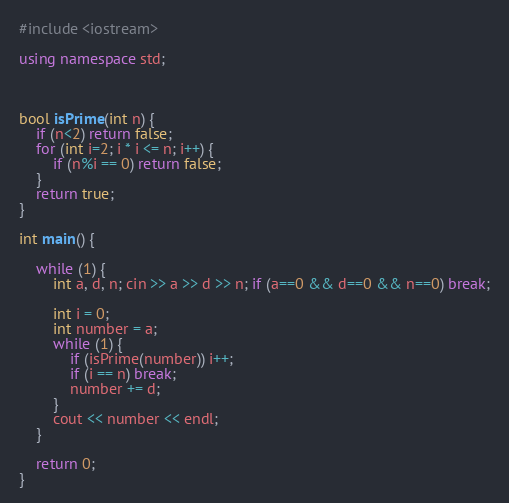Convert code to text. <code><loc_0><loc_0><loc_500><loc_500><_C++_>#include <iostream>

using namespace std;



bool isPrime(int n) {
	if (n<2) return false;
	for (int i=2; i * i <= n; i++) {
		if (n%i == 0) return false;
	}
	return true;
}

int main() {
	
	while (1) {
		int a, d, n; cin >> a >> d >> n; if (a==0 && d==0 && n==0) break;
		
		int i = 0;
		int number = a;
		while (1) {
			if (isPrime(number)) i++;
			if (i == n) break;
			number += d;
		}
		cout << number << endl;		
	}
	
	return 0;
}</code> 